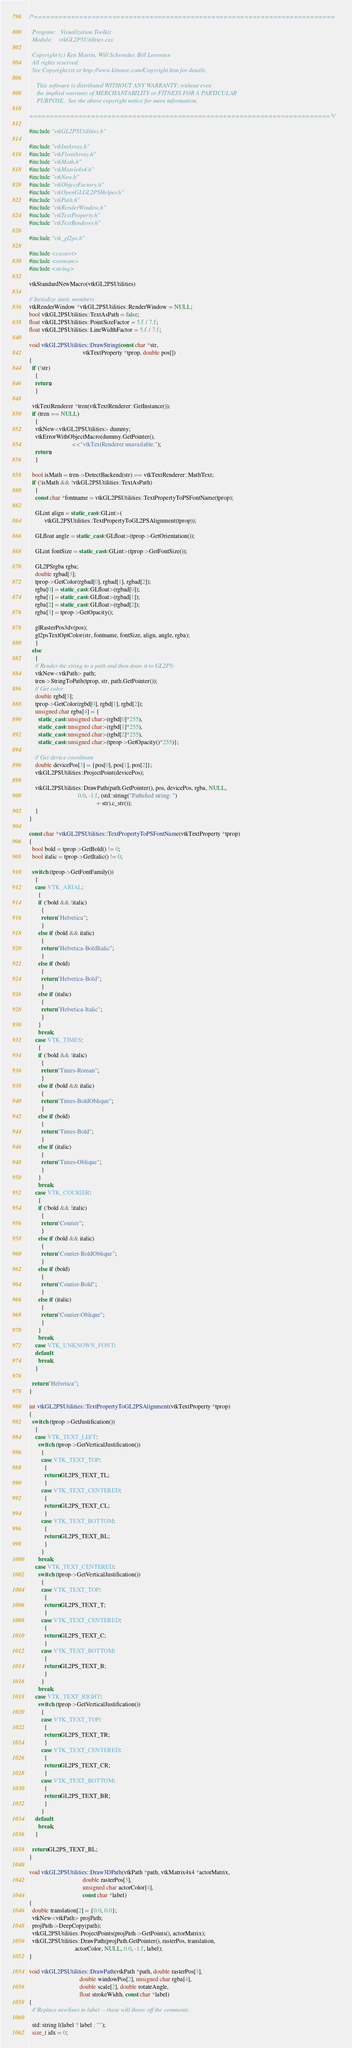Convert code to text. <code><loc_0><loc_0><loc_500><loc_500><_C++_>/*=========================================================================

  Program:   Visualization Toolkit
  Module:    vtkGL2PSUtilities.cxx

  Copyright (c) Ken Martin, Will Schroeder, Bill Lorensen
  All rights reserved.
  See Copyright.txt or http://www.kitware.com/Copyright.htm for details.

     This software is distributed WITHOUT ANY WARRANTY; without even
     the implied warranty of MERCHANTABILITY or FITNESS FOR A PARTICULAR
     PURPOSE.  See the above copyright notice for more information.

=========================================================================*/

#include "vtkGL2PSUtilities.h"

#include "vtkIntArray.h"
#include "vtkFloatArray.h"
#include "vtkMath.h"
#include "vtkMatrix4x4.h"
#include "vtkNew.h"
#include "vtkObjectFactory.h"
#include "vtkOpenGLGL2PSHelper.h"
#include "vtkPath.h"
#include "vtkRenderWindow.h"
#include "vtkTextProperty.h"
#include "vtkTextRenderer.h"

#include "vtk_gl2ps.h"

#include <cassert>
#include <sstream>
#include <string>

vtkStandardNewMacro(vtkGL2PSUtilities)

// Initialize static members
vtkRenderWindow *vtkGL2PSUtilities::RenderWindow = NULL;
bool vtkGL2PSUtilities::TextAsPath = false;
float vtkGL2PSUtilities::PointSizeFactor = 5.f / 7.f;
float vtkGL2PSUtilities::LineWidthFactor = 5.f / 7.f;

void vtkGL2PSUtilities::DrawString(const char *str,
                                   vtkTextProperty *tprop, double pos[])
{
  if (!str)
    {
    return;
    }

  vtkTextRenderer *tren(vtkTextRenderer::GetInstance());
  if (tren == NULL)
    {
    vtkNew<vtkGL2PSUtilities> dummy;
    vtkErrorWithObjectMacro(dummy.GetPointer(),
                            <<"vtkTextRenderer unavailable.");
    return;
    }

  bool isMath = tren->DetectBackend(str) == vtkTextRenderer::MathText;
  if (!isMath && !vtkGL2PSUtilities::TextAsPath)
    {
    const char *fontname = vtkGL2PSUtilities::TextPropertyToPSFontName(tprop);

    GLint align = static_cast<GLint>(
          vtkGL2PSUtilities::TextPropertyToGL2PSAlignment(tprop));

    GLfloat angle = static_cast<GLfloat>(tprop->GetOrientation());

    GLint fontSize = static_cast<GLint>(tprop->GetFontSize());

    GL2PSrgba rgba;
    double rgbad[3];
    tprop->GetColor(rgbad[0], rgbad[1], rgbad[2]);
    rgba[0] = static_cast<GLfloat>(rgbad[0]);
    rgba[1] = static_cast<GLfloat>(rgbad[1]);
    rgba[2] = static_cast<GLfloat>(rgbad[2]);
    rgba[3] = tprop->GetOpacity();

    glRasterPos3dv(pos);
    gl2psTextOptColor(str, fontname, fontSize, align, angle, rgba);
    }
  else
    {
    // Render the string to a path and then draw it to GL2PS:
    vtkNew<vtkPath> path;
    tren->StringToPath(tprop, str, path.GetPointer());
    // Get color
    double rgbd[3];
    tprop->GetColor(rgbd[0], rgbd[1], rgbd[2]);
    unsigned char rgba[4] = {
      static_cast<unsigned char>(rgbd[0]*255),
      static_cast<unsigned char>(rgbd[1]*255),
      static_cast<unsigned char>(rgbd[2]*255),
      static_cast<unsigned char>(tprop->GetOpacity()*255)};

    // Get device coordinate
    double devicePos[3] = {pos[0], pos[1], pos[2]};
    vtkGL2PSUtilities::ProjectPoint(devicePos);

    vtkGL2PSUtilities::DrawPath(path.GetPointer(), pos, devicePos, rgba, NULL,
                                0.0, -1.f, (std::string("Pathified string: ")
                                            + str).c_str());
    }
}

const char *vtkGL2PSUtilities::TextPropertyToPSFontName(vtkTextProperty *tprop)
{
  bool bold = tprop->GetBold() != 0;
  bool italic = tprop->GetItalic() != 0;

  switch (tprop->GetFontFamily())
    {
    case VTK_ARIAL:
      {
      if (!bold && !italic)
        {
        return "Helvetica";
        }
      else if (bold && italic)
        {
        return "Helvetica-BoldItalic";
        }
      else if (bold)
        {
        return "Helvetica-Bold";
        }
      else if (italic)
        {
        return "Helvetica-Italic";
        }
      }
      break;
    case VTK_TIMES:
      {
      if (!bold && !italic)
        {
        return "Times-Roman";
        }
      else if (bold && italic)
        {
        return "Times-BoldOblique";
        }
      else if (bold)
        {
        return "Times-Bold";
        }
      else if (italic)
        {
        return "Times-Oblique";
        }
      }
      break;
    case VTK_COURIER:
      {
      if (!bold && !italic)
        {
        return "Courier";
        }
      else if (bold && italic)
        {
        return "Courier-BoldOblique";
        }
      else if (bold)
        {
        return "Courier-Bold";
        }
      else if (italic)
        {
        return "Courier-Oblique";
        }
      }
      break;
    case VTK_UNKNOWN_FONT:
    default:
      break;
    }

  return "Helvetica";
}

int vtkGL2PSUtilities::TextPropertyToGL2PSAlignment(vtkTextProperty *tprop)
{
  switch (tprop->GetJustification())
    {
    case VTK_TEXT_LEFT:
      switch (tprop->GetVerticalJustification())
        {
        case VTK_TEXT_TOP:
          {
          return GL2PS_TEXT_TL;
          }
        case VTK_TEXT_CENTERED:
          {
          return GL2PS_TEXT_CL;
          }
        case VTK_TEXT_BOTTOM:
          {
          return GL2PS_TEXT_BL;
          }
        }
      break;
    case VTK_TEXT_CENTERED:
      switch (tprop->GetVerticalJustification())
        {
        case VTK_TEXT_TOP:
          {
          return GL2PS_TEXT_T;
          }
        case VTK_TEXT_CENTERED:
          {
          return GL2PS_TEXT_C;
          }
        case VTK_TEXT_BOTTOM:
          {
          return GL2PS_TEXT_B;
          }
        }
      break;
    case VTK_TEXT_RIGHT:
      switch (tprop->GetVerticalJustification())
        {
        case VTK_TEXT_TOP:
          {
          return GL2PS_TEXT_TR;
          }
        case VTK_TEXT_CENTERED:
          {
          return GL2PS_TEXT_CR;
          }
        case VTK_TEXT_BOTTOM:
          {
          return GL2PS_TEXT_BR;
          }
        }
    default:
      break;
    }

  return GL2PS_TEXT_BL;
}

void vtkGL2PSUtilities::Draw3DPath(vtkPath *path, vtkMatrix4x4 *actorMatrix,
                                   double rasterPos[3],
                                   unsigned char actorColor[4],
                                   const char *label)
{
  double translation[2] = {0.0, 0.0};
  vtkNew<vtkPath> projPath;
  projPath->DeepCopy(path);
  vtkGL2PSUtilities::ProjectPoints(projPath->GetPoints(), actorMatrix);
  vtkGL2PSUtilities::DrawPath(projPath.GetPointer(), rasterPos, translation,
                              actorColor, NULL, 0.0, -1.f, label);
}

void vtkGL2PSUtilities::DrawPath(vtkPath *path, double rasterPos[3],
                                 double windowPos[2], unsigned char rgba[4],
                                 double scale[2], double rotateAngle,
                                 float strokeWidth, const char *label)
{
  // Replace newlines in label -- these will throw off the comments.

  std::string l(label ? label : "");
  size_t idx = 0;</code> 